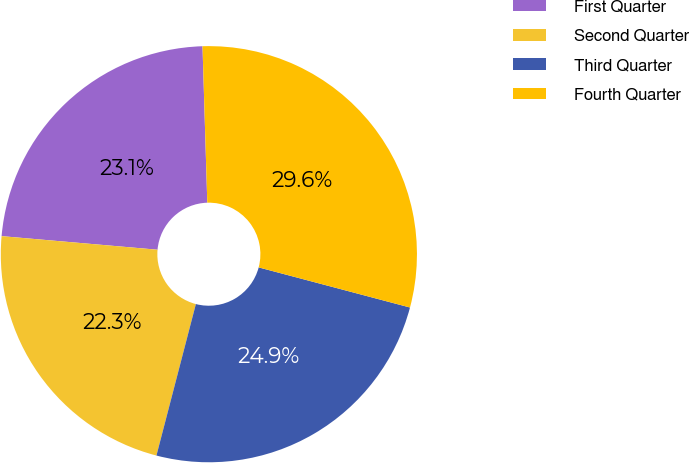<chart> <loc_0><loc_0><loc_500><loc_500><pie_chart><fcel>First Quarter<fcel>Second Quarter<fcel>Third Quarter<fcel>Fourth Quarter<nl><fcel>23.13%<fcel>22.33%<fcel>24.93%<fcel>29.61%<nl></chart> 